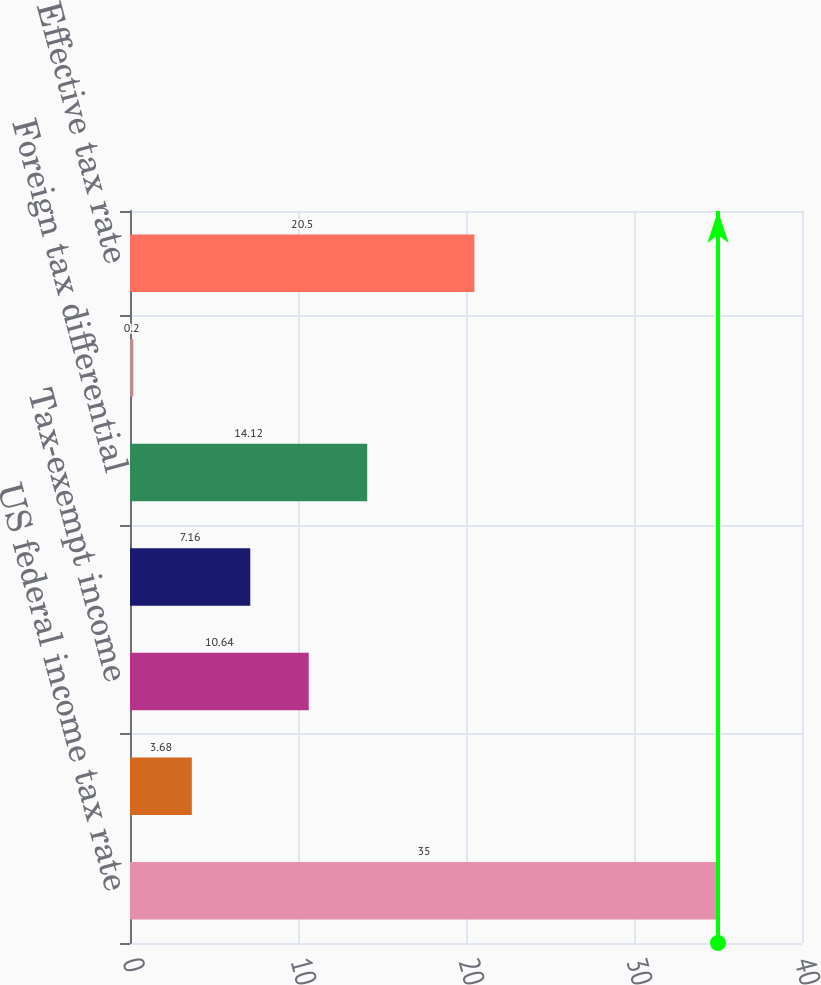Convert chart. <chart><loc_0><loc_0><loc_500><loc_500><bar_chart><fcel>US federal income tax rate<fcel>State taxes net of federal<fcel>Tax-exempt income<fcel>Tax credits<fcel>Foreign tax differential<fcel>Other net<fcel>Effective tax rate<nl><fcel>35<fcel>3.68<fcel>10.64<fcel>7.16<fcel>14.12<fcel>0.2<fcel>20.5<nl></chart> 